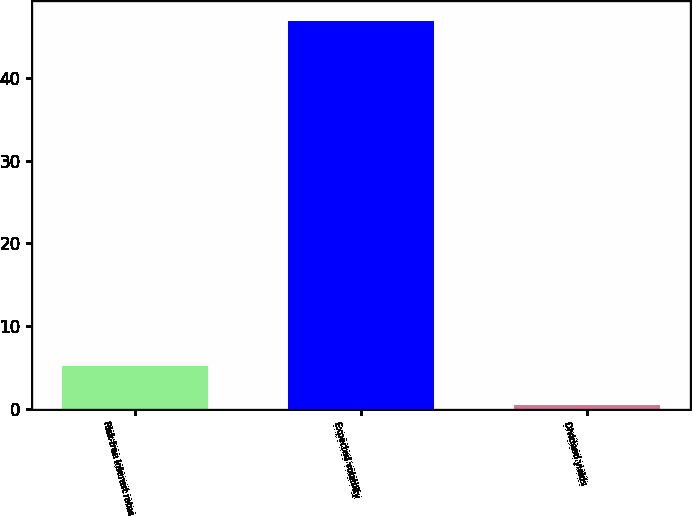Convert chart. <chart><loc_0><loc_0><loc_500><loc_500><bar_chart><fcel>Risk-free interest rates<fcel>Expected volatility<fcel>Dividend yields<nl><fcel>5.1<fcel>47<fcel>0.44<nl></chart> 